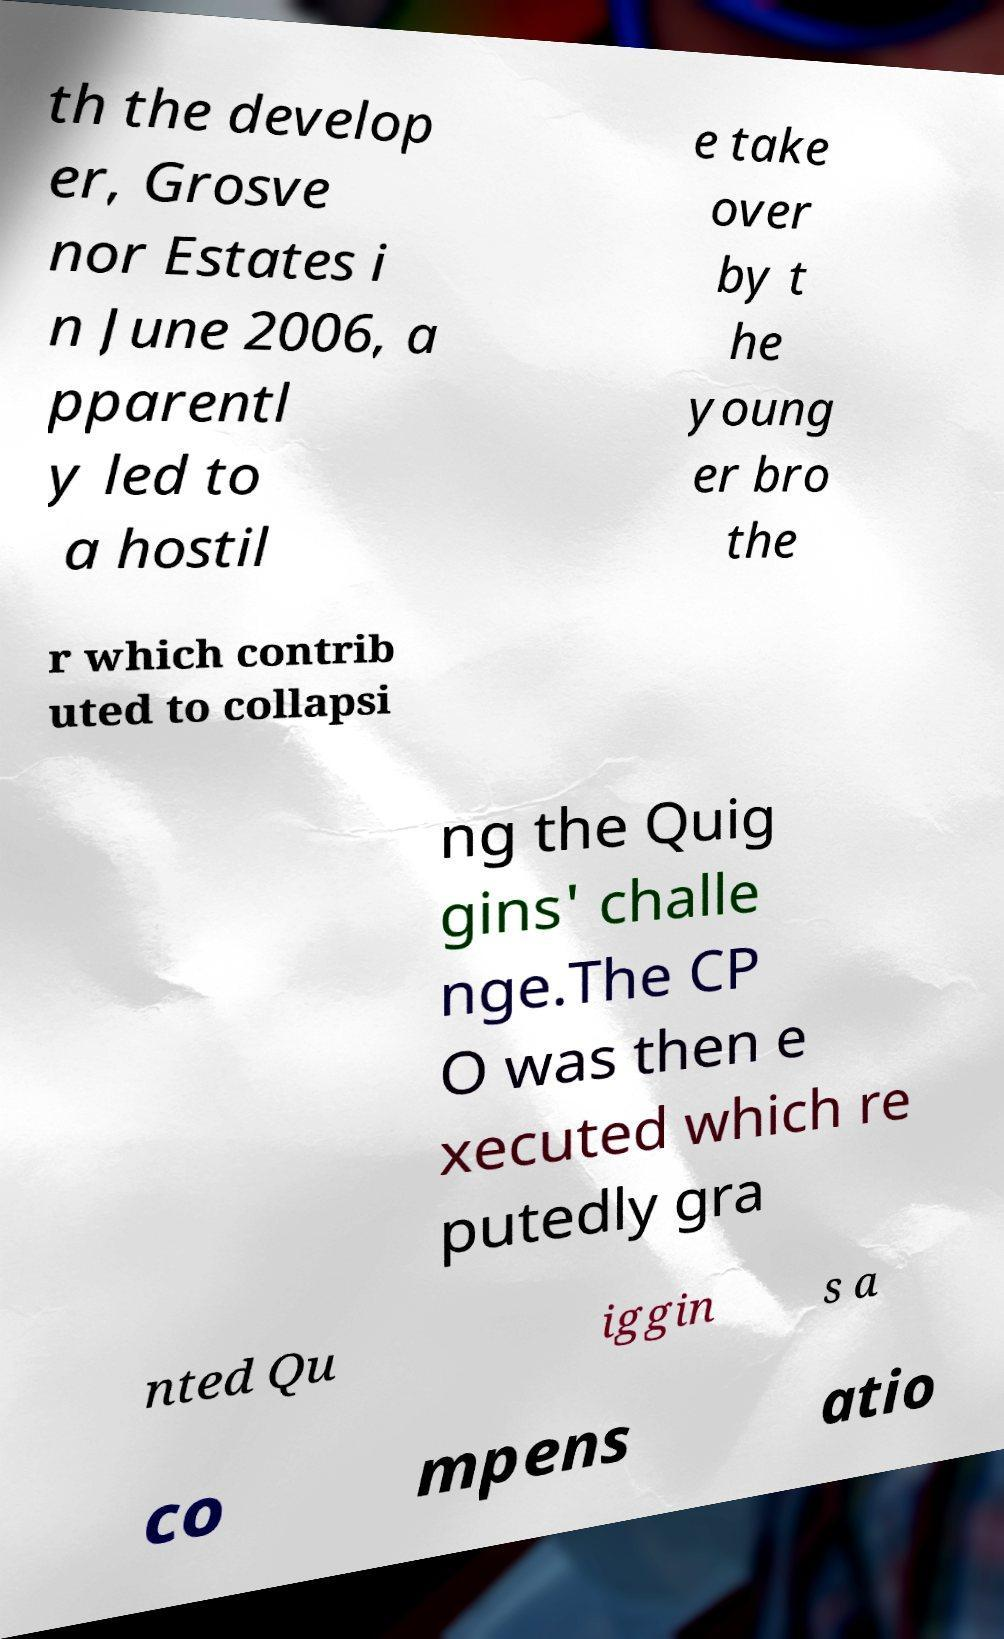Can you accurately transcribe the text from the provided image for me? th the develop er, Grosve nor Estates i n June 2006, a pparentl y led to a hostil e take over by t he young er bro the r which contrib uted to collapsi ng the Quig gins' challe nge.The CP O was then e xecuted which re putedly gra nted Qu iggin s a co mpens atio 